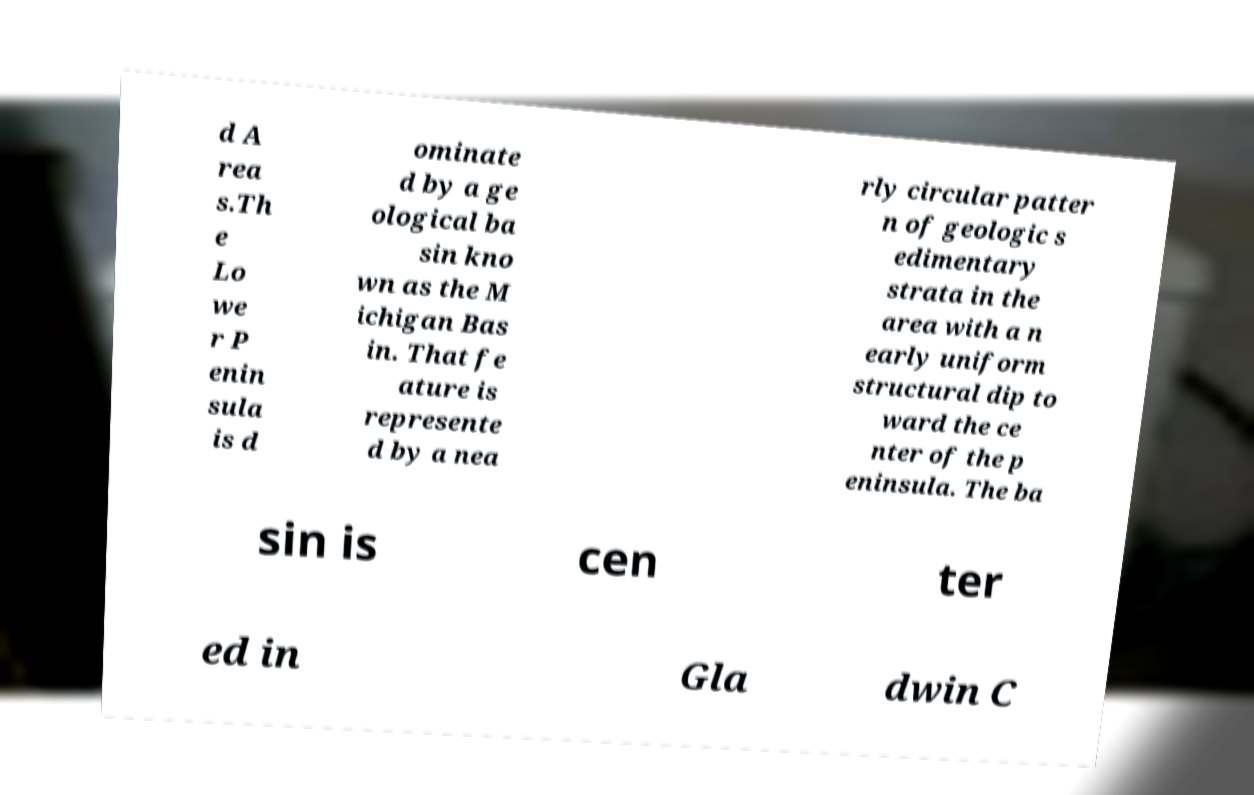I need the written content from this picture converted into text. Can you do that? d A rea s.Th e Lo we r P enin sula is d ominate d by a ge ological ba sin kno wn as the M ichigan Bas in. That fe ature is represente d by a nea rly circular patter n of geologic s edimentary strata in the area with a n early uniform structural dip to ward the ce nter of the p eninsula. The ba sin is cen ter ed in Gla dwin C 